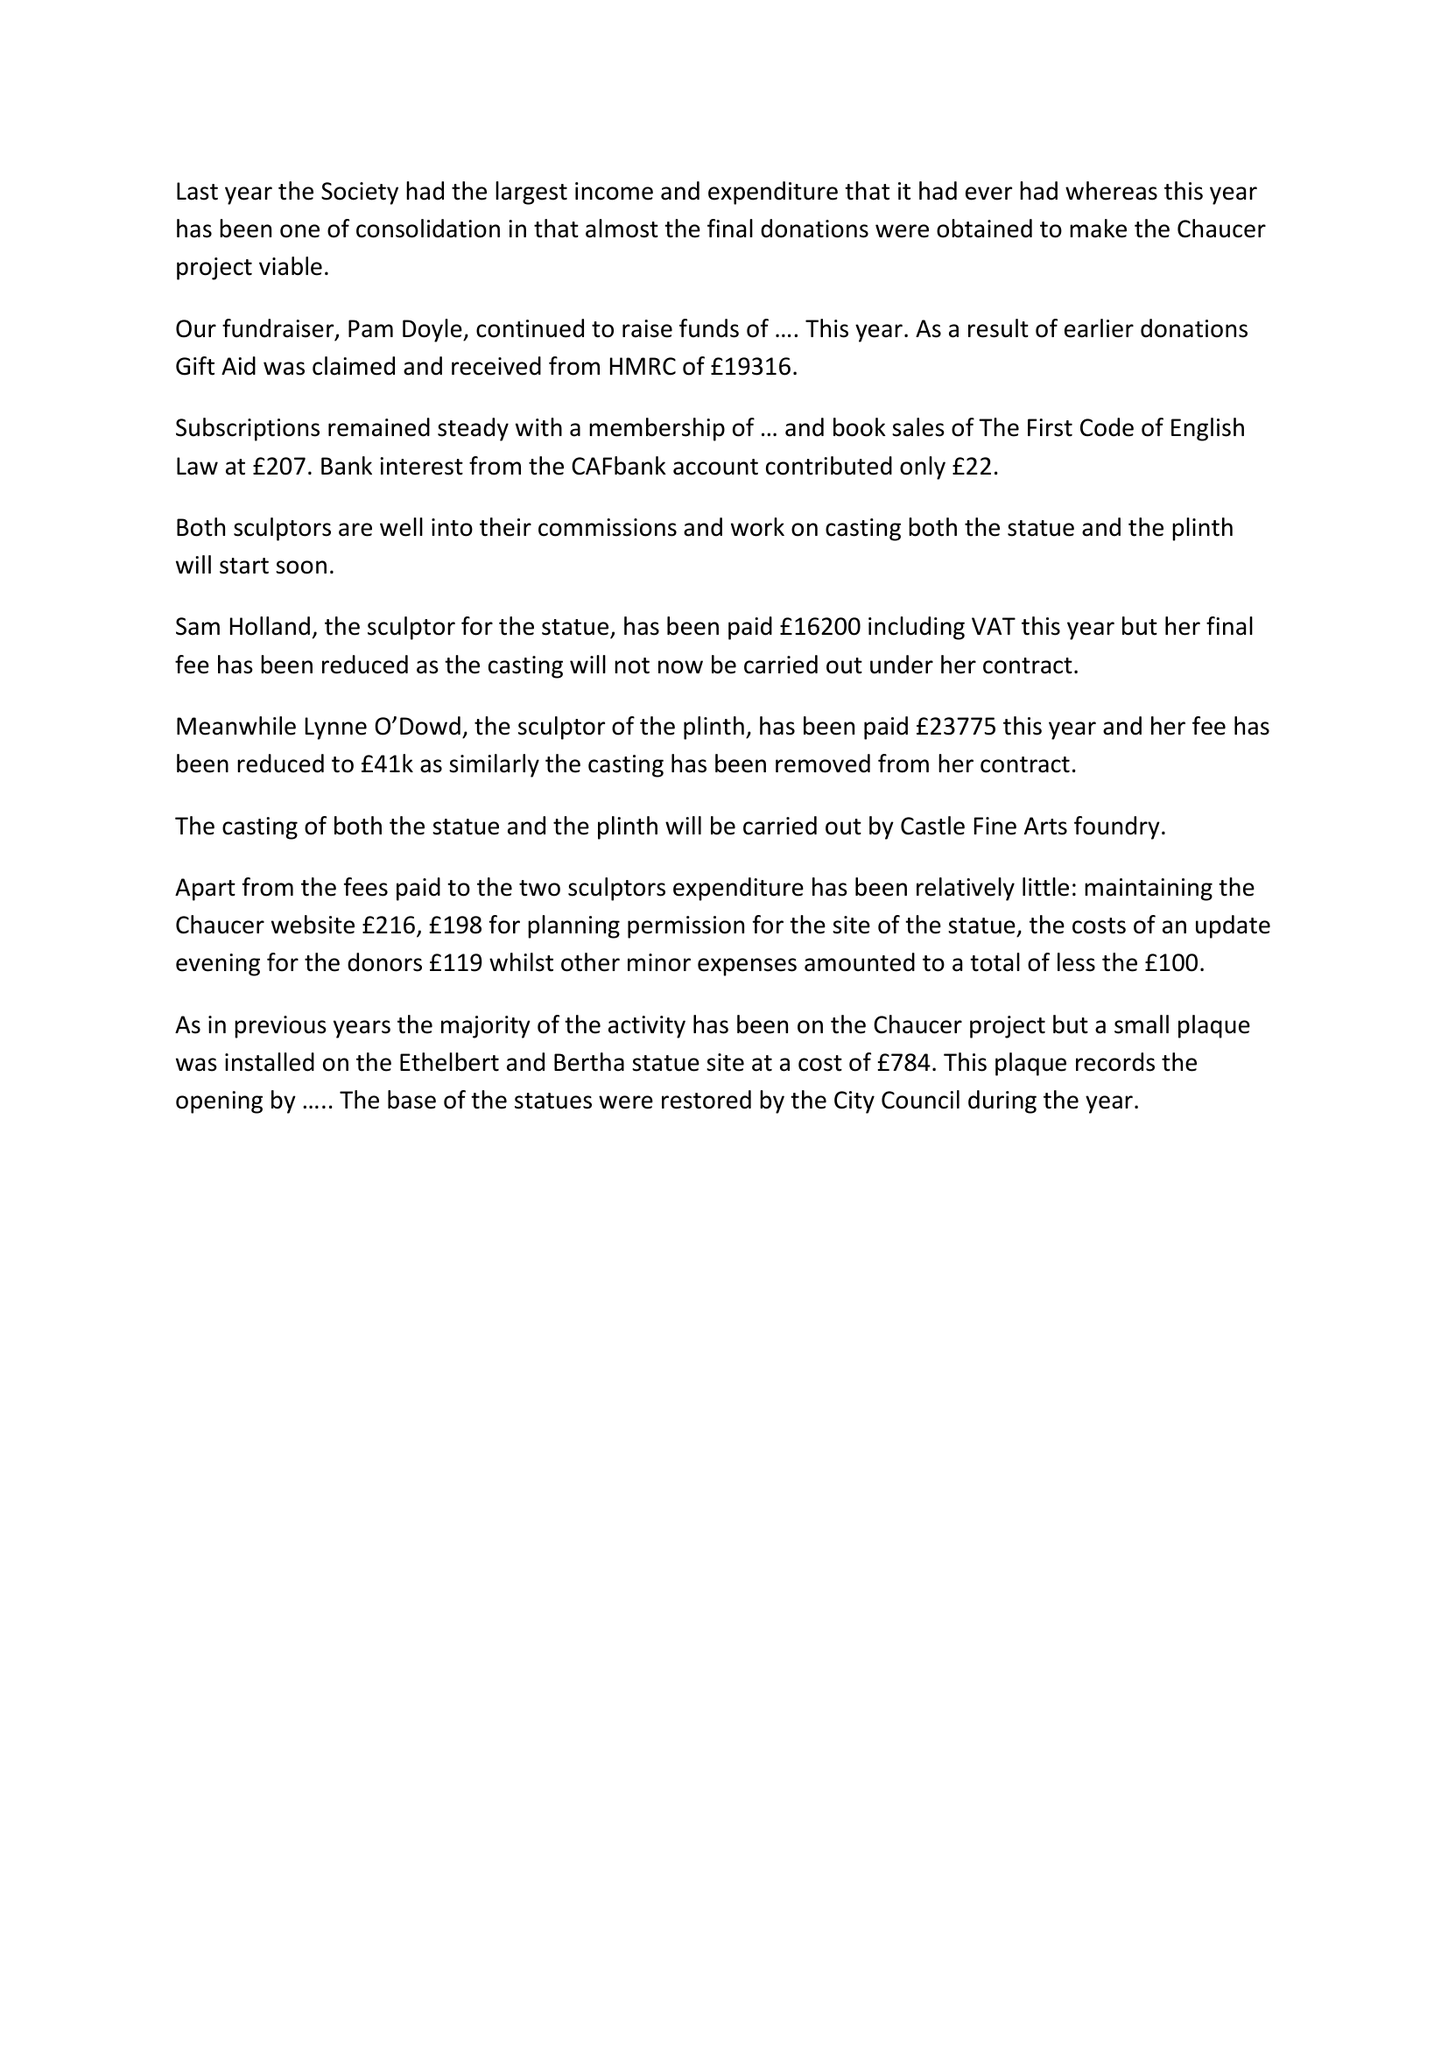What is the value for the charity_number?
Answer the question using a single word or phrase. None 